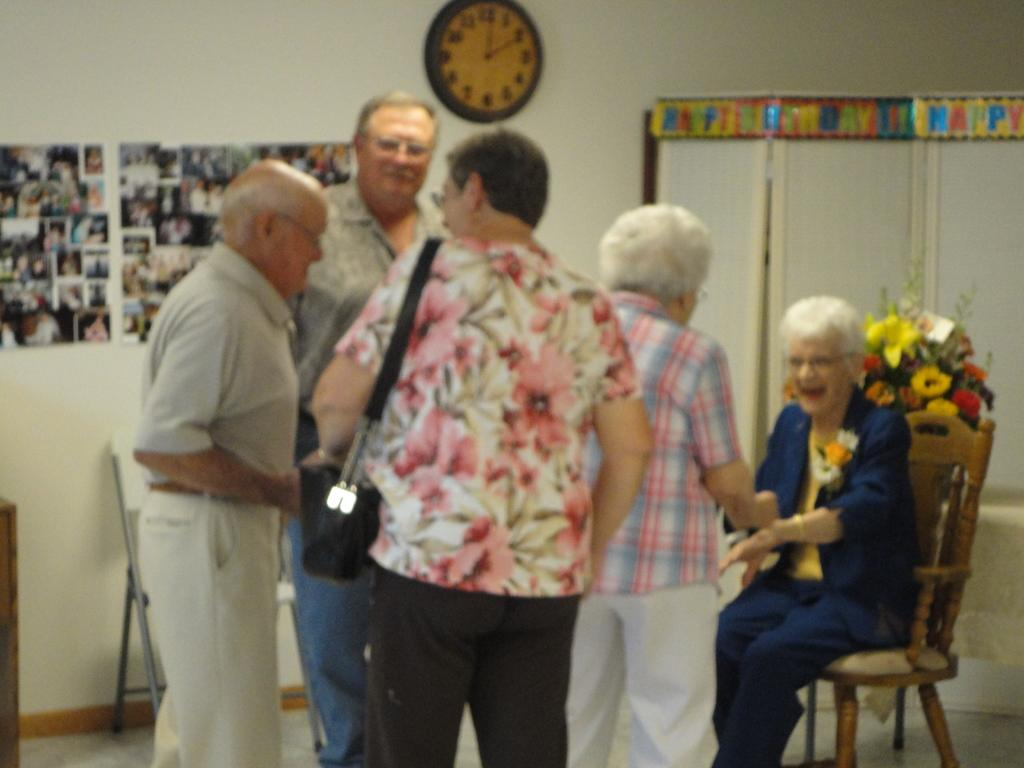<image>
Summarize the visual content of the image. Several people greet each other under a wall clock showing a time of 2:00 on it. 